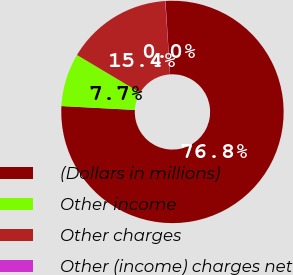<chart> <loc_0><loc_0><loc_500><loc_500><pie_chart><fcel>(Dollars in millions)<fcel>Other income<fcel>Other charges<fcel>Other (income) charges net<nl><fcel>76.84%<fcel>7.72%<fcel>15.4%<fcel>0.04%<nl></chart> 